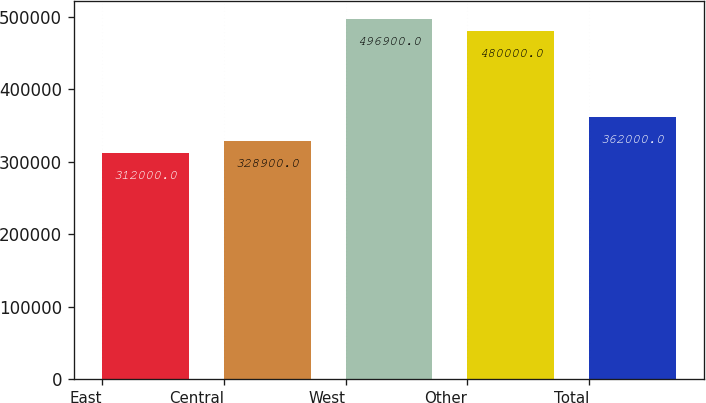<chart> <loc_0><loc_0><loc_500><loc_500><bar_chart><fcel>East<fcel>Central<fcel>West<fcel>Other<fcel>Total<nl><fcel>312000<fcel>328900<fcel>496900<fcel>480000<fcel>362000<nl></chart> 